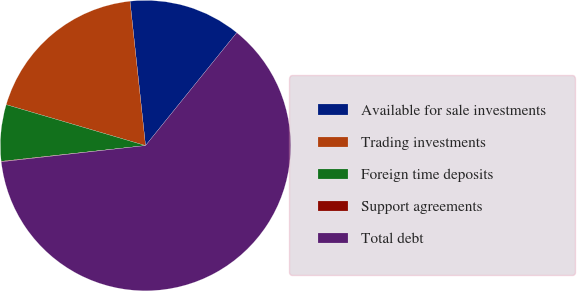Convert chart to OTSL. <chart><loc_0><loc_0><loc_500><loc_500><pie_chart><fcel>Available for sale investments<fcel>Trading investments<fcel>Foreign time deposits<fcel>Support agreements<fcel>Total debt<nl><fcel>12.52%<fcel>18.75%<fcel>6.28%<fcel>0.05%<fcel>62.4%<nl></chart> 